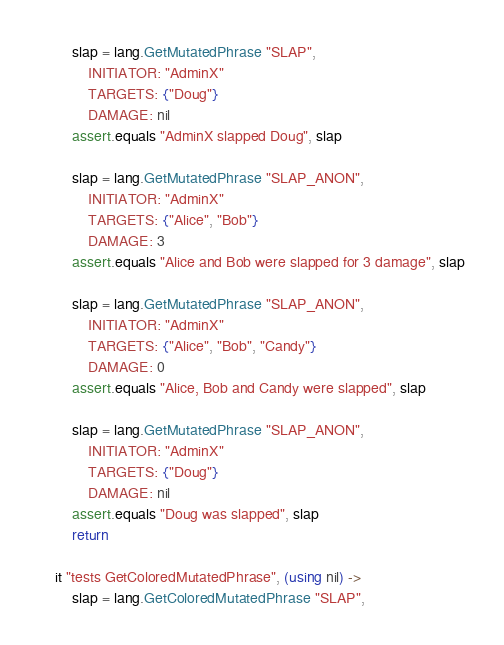Convert code to text. <code><loc_0><loc_0><loc_500><loc_500><_MoonScript_>		slap = lang.GetMutatedPhrase "SLAP",
			INITIATOR: "AdminX"
			TARGETS: {"Doug"}
			DAMAGE: nil
		assert.equals "AdminX slapped Doug", slap

		slap = lang.GetMutatedPhrase "SLAP_ANON",
			INITIATOR: "AdminX"
			TARGETS: {"Alice", "Bob"}
			DAMAGE: 3
		assert.equals "Alice and Bob were slapped for 3 damage", slap

		slap = lang.GetMutatedPhrase "SLAP_ANON",
			INITIATOR: "AdminX"
			TARGETS: {"Alice", "Bob", "Candy"}
			DAMAGE: 0
		assert.equals "Alice, Bob and Candy were slapped", slap

		slap = lang.GetMutatedPhrase "SLAP_ANON",
			INITIATOR: "AdminX"
			TARGETS: {"Doug"}
			DAMAGE: nil
		assert.equals "Doug was slapped", slap
		return

	it "tests GetColoredMutatedPhrase", (using nil) ->
		slap = lang.GetColoredMutatedPhrase "SLAP",</code> 